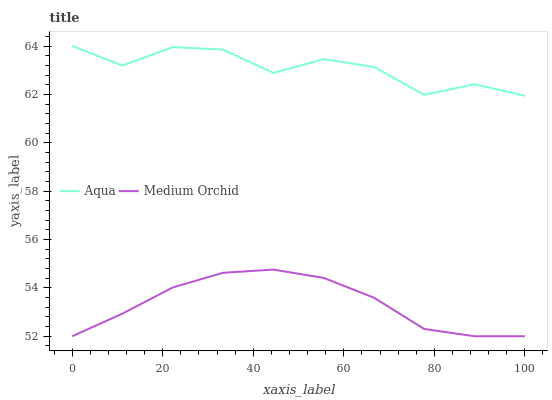Does Medium Orchid have the minimum area under the curve?
Answer yes or no. Yes. Does Aqua have the maximum area under the curve?
Answer yes or no. Yes. Does Aqua have the minimum area under the curve?
Answer yes or no. No. Is Medium Orchid the smoothest?
Answer yes or no. Yes. Is Aqua the roughest?
Answer yes or no. Yes. Is Aqua the smoothest?
Answer yes or no. No. Does Medium Orchid have the lowest value?
Answer yes or no. Yes. Does Aqua have the lowest value?
Answer yes or no. No. Does Aqua have the highest value?
Answer yes or no. Yes. Is Medium Orchid less than Aqua?
Answer yes or no. Yes. Is Aqua greater than Medium Orchid?
Answer yes or no. Yes. Does Medium Orchid intersect Aqua?
Answer yes or no. No. 